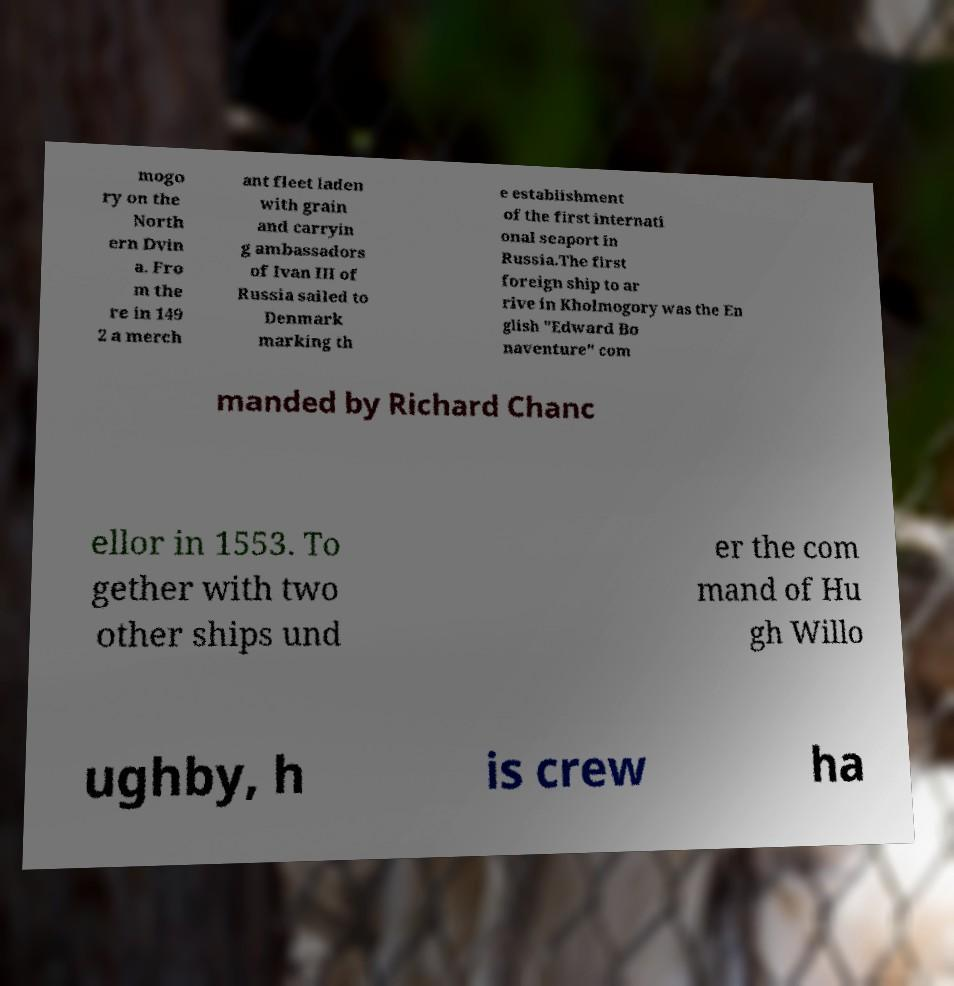Could you extract and type out the text from this image? mogo ry on the North ern Dvin a. Fro m the re in 149 2 a merch ant fleet laden with grain and carryin g ambassadors of Ivan III of Russia sailed to Denmark marking th e establishment of the first internati onal seaport in Russia.The first foreign ship to ar rive in Kholmogory was the En glish "Edward Bo naventure" com manded by Richard Chanc ellor in 1553. To gether with two other ships und er the com mand of Hu gh Willo ughby, h is crew ha 